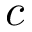Convert formula to latex. <formula><loc_0><loc_0><loc_500><loc_500>c</formula> 